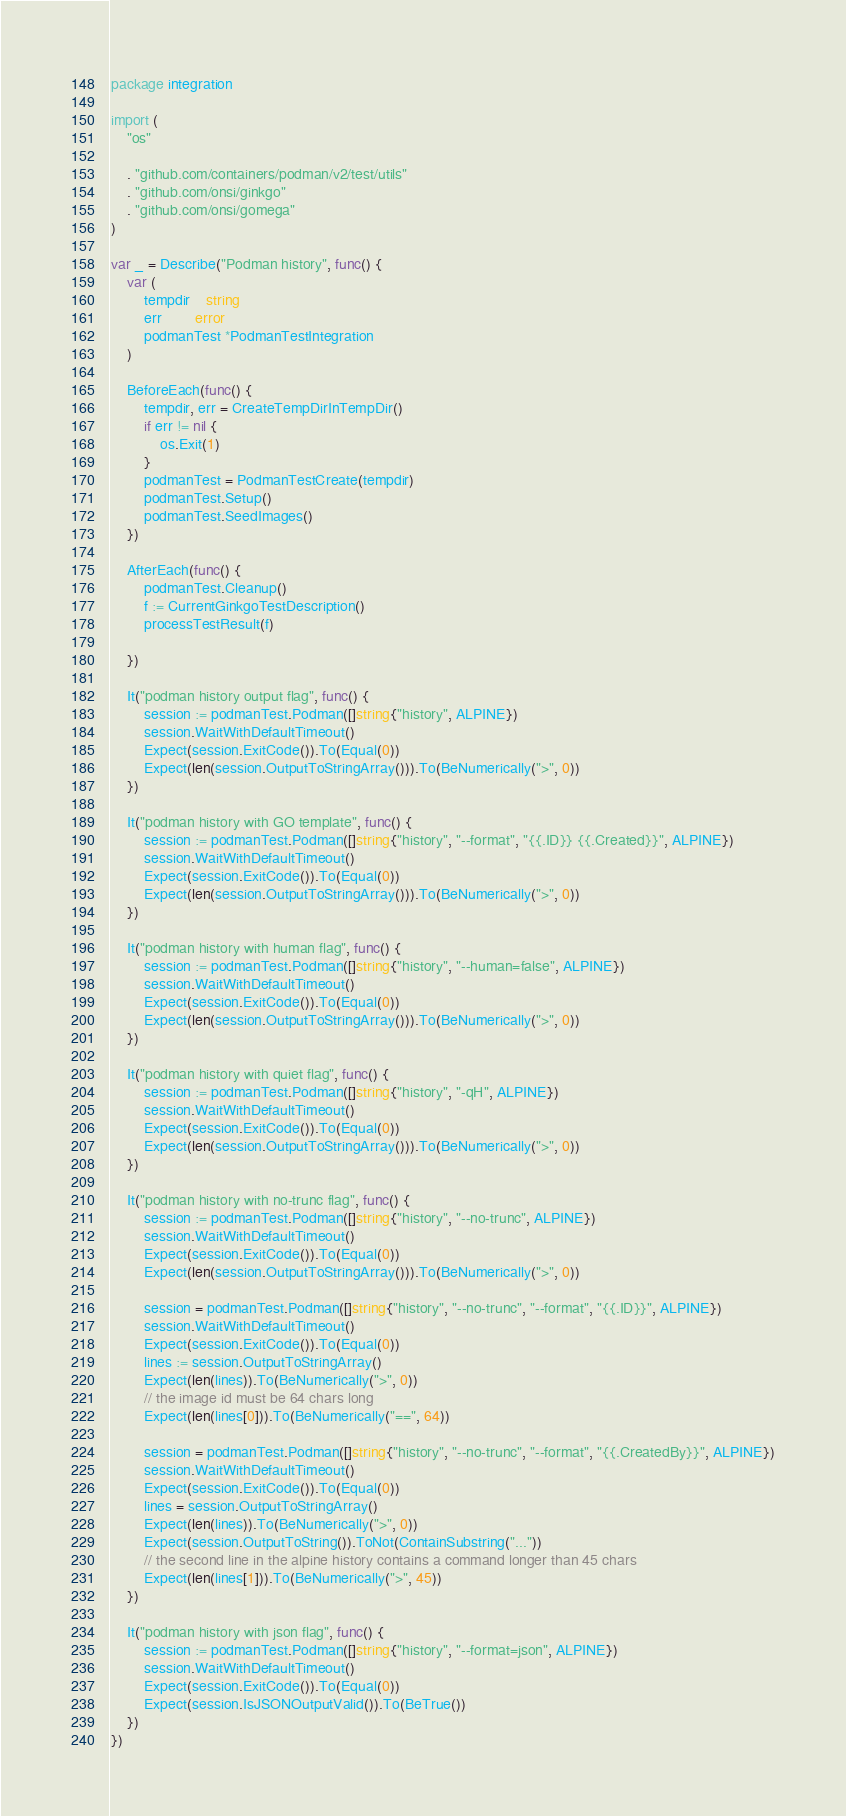<code> <loc_0><loc_0><loc_500><loc_500><_Go_>package integration

import (
	"os"

	. "github.com/containers/podman/v2/test/utils"
	. "github.com/onsi/ginkgo"
	. "github.com/onsi/gomega"
)

var _ = Describe("Podman history", func() {
	var (
		tempdir    string
		err        error
		podmanTest *PodmanTestIntegration
	)

	BeforeEach(func() {
		tempdir, err = CreateTempDirInTempDir()
		if err != nil {
			os.Exit(1)
		}
		podmanTest = PodmanTestCreate(tempdir)
		podmanTest.Setup()
		podmanTest.SeedImages()
	})

	AfterEach(func() {
		podmanTest.Cleanup()
		f := CurrentGinkgoTestDescription()
		processTestResult(f)

	})

	It("podman history output flag", func() {
		session := podmanTest.Podman([]string{"history", ALPINE})
		session.WaitWithDefaultTimeout()
		Expect(session.ExitCode()).To(Equal(0))
		Expect(len(session.OutputToStringArray())).To(BeNumerically(">", 0))
	})

	It("podman history with GO template", func() {
		session := podmanTest.Podman([]string{"history", "--format", "{{.ID}} {{.Created}}", ALPINE})
		session.WaitWithDefaultTimeout()
		Expect(session.ExitCode()).To(Equal(0))
		Expect(len(session.OutputToStringArray())).To(BeNumerically(">", 0))
	})

	It("podman history with human flag", func() {
		session := podmanTest.Podman([]string{"history", "--human=false", ALPINE})
		session.WaitWithDefaultTimeout()
		Expect(session.ExitCode()).To(Equal(0))
		Expect(len(session.OutputToStringArray())).To(BeNumerically(">", 0))
	})

	It("podman history with quiet flag", func() {
		session := podmanTest.Podman([]string{"history", "-qH", ALPINE})
		session.WaitWithDefaultTimeout()
		Expect(session.ExitCode()).To(Equal(0))
		Expect(len(session.OutputToStringArray())).To(BeNumerically(">", 0))
	})

	It("podman history with no-trunc flag", func() {
		session := podmanTest.Podman([]string{"history", "--no-trunc", ALPINE})
		session.WaitWithDefaultTimeout()
		Expect(session.ExitCode()).To(Equal(0))
		Expect(len(session.OutputToStringArray())).To(BeNumerically(">", 0))

		session = podmanTest.Podman([]string{"history", "--no-trunc", "--format", "{{.ID}}", ALPINE})
		session.WaitWithDefaultTimeout()
		Expect(session.ExitCode()).To(Equal(0))
		lines := session.OutputToStringArray()
		Expect(len(lines)).To(BeNumerically(">", 0))
		// the image id must be 64 chars long
		Expect(len(lines[0])).To(BeNumerically("==", 64))

		session = podmanTest.Podman([]string{"history", "--no-trunc", "--format", "{{.CreatedBy}}", ALPINE})
		session.WaitWithDefaultTimeout()
		Expect(session.ExitCode()).To(Equal(0))
		lines = session.OutputToStringArray()
		Expect(len(lines)).To(BeNumerically(">", 0))
		Expect(session.OutputToString()).ToNot(ContainSubstring("..."))
		// the second line in the alpine history contains a command longer than 45 chars
		Expect(len(lines[1])).To(BeNumerically(">", 45))
	})

	It("podman history with json flag", func() {
		session := podmanTest.Podman([]string{"history", "--format=json", ALPINE})
		session.WaitWithDefaultTimeout()
		Expect(session.ExitCode()).To(Equal(0))
		Expect(session.IsJSONOutputValid()).To(BeTrue())
	})
})
</code> 